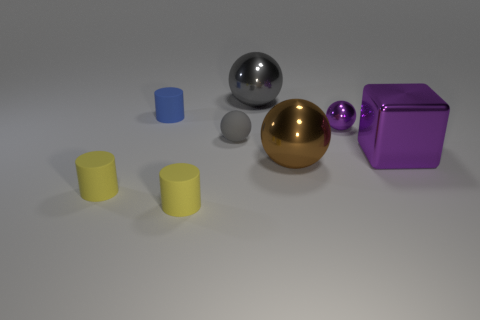How many things are either tiny things that are on the left side of the blue rubber thing or metallic objects?
Provide a succinct answer. 5. Is the number of cubes behind the big metal block less than the number of tiny yellow matte things that are to the left of the small gray rubber ball?
Your answer should be compact. Yes. How many other objects are the same size as the brown shiny object?
Your answer should be very brief. 2. Do the blue object and the small object left of the small blue matte object have the same material?
Your answer should be compact. Yes. What number of objects are small objects left of the big gray shiny sphere or large balls behind the large cube?
Give a very brief answer. 5. The tiny matte ball is what color?
Keep it short and to the point. Gray. Is the number of metallic cubes that are in front of the brown thing less than the number of big brown shiny things?
Make the answer very short. Yes. Is there any other thing that has the same shape as the small blue matte thing?
Your answer should be compact. Yes. Are there any large blocks?
Give a very brief answer. Yes. Are there fewer large red metallic things than things?
Provide a short and direct response. Yes. 